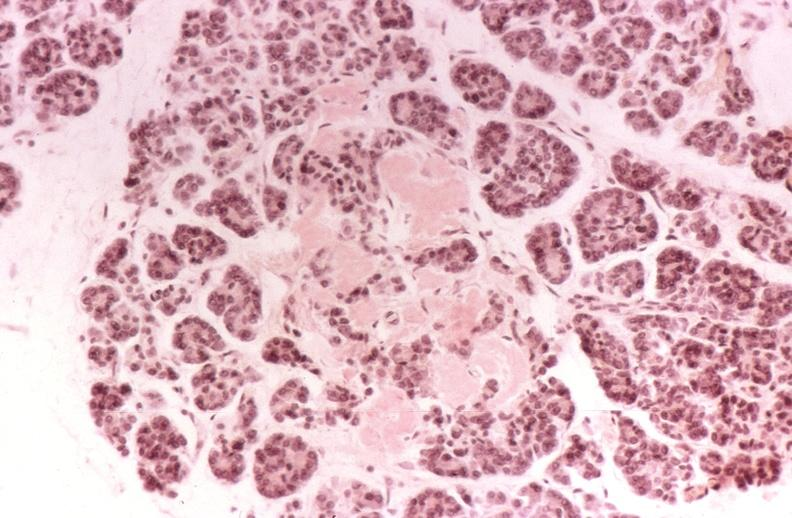does coronary atherosclerosis show kidney, glomerular amyloid, diabetes mellitus?
Answer the question using a single word or phrase. No 